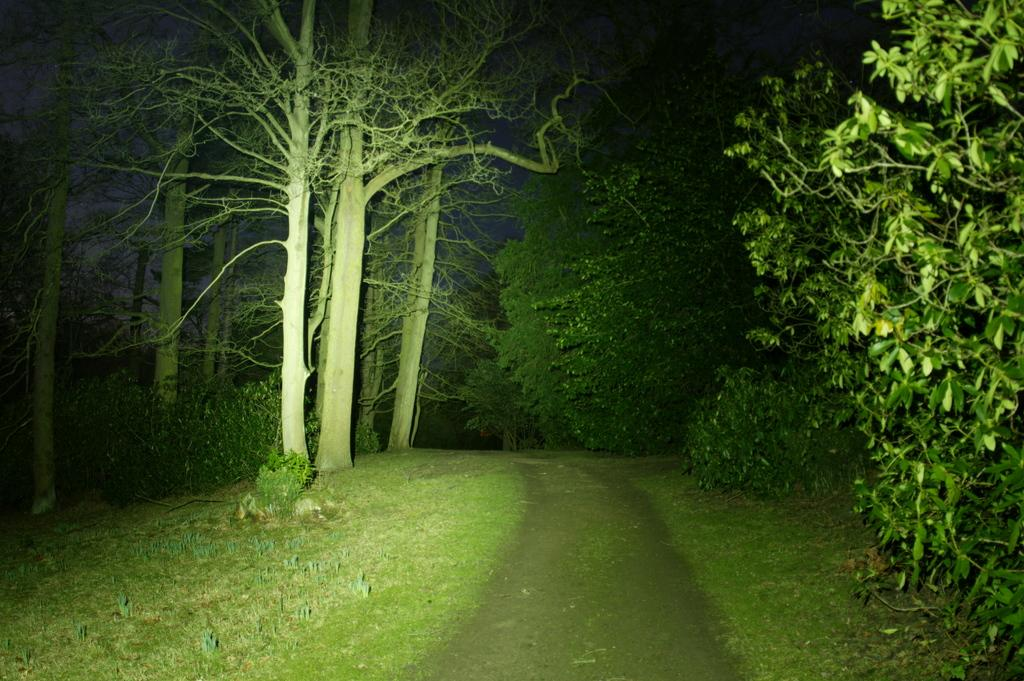What type of natural environment is visible in the foreground of the image? There is a grassland in the foreground area of the image. What feature can be seen in the grassland area? There is a path in the foreground area of the image. What type of vegetation is visible in the background of the image? There are trees in the background of the image. How many beds can be seen in the image? There are no beds present in the image. Is there a knife visible in the image? There is no knife present in the image. 